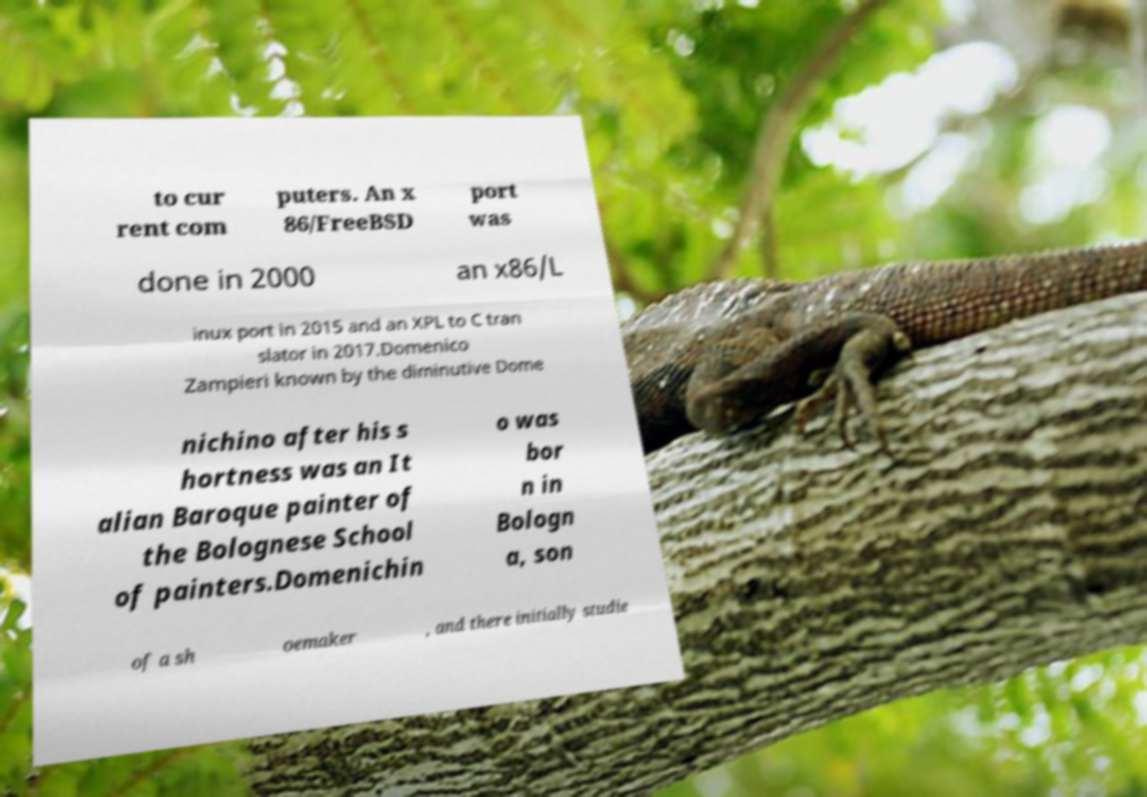I need the written content from this picture converted into text. Can you do that? to cur rent com puters. An x 86/FreeBSD port was done in 2000 an x86/L inux port in 2015 and an XPL to C tran slator in 2017.Domenico Zampieri known by the diminutive Dome nichino after his s hortness was an It alian Baroque painter of the Bolognese School of painters.Domenichin o was bor n in Bologn a, son of a sh oemaker , and there initially studie 